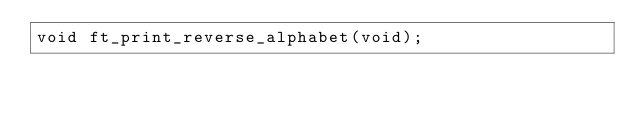<code> <loc_0><loc_0><loc_500><loc_500><_C_>void ft_print_reverse_alphabet(void);
</code> 